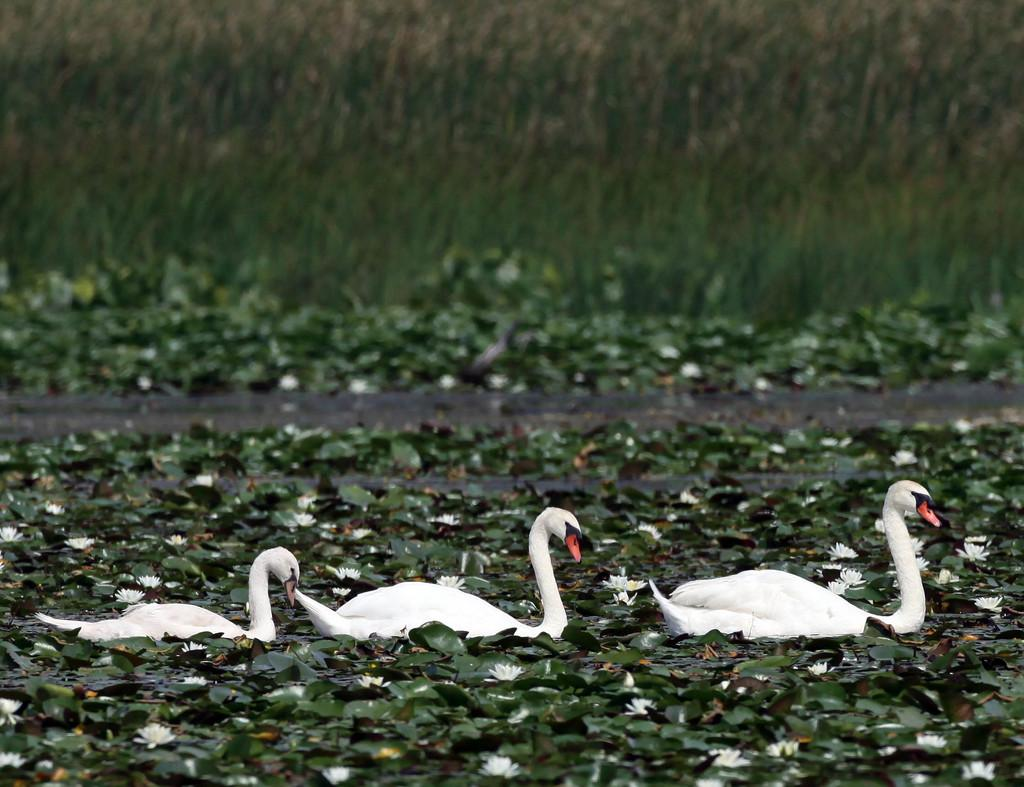What type of animals can be seen in the water in the image? There are swans in the water in the image. What else can be seen floating on the water? Leaves and flowers are floating on the water in the image. What type of vegetation is visible in the background? There is grass visible in the background of the image. What type of property can be seen in the background of the image? There is no property visible in the background of the image; it features grass and water. How does the air affect the swans in the image? The air does not affect the swans in the image; the focus is on their presence in the water. 